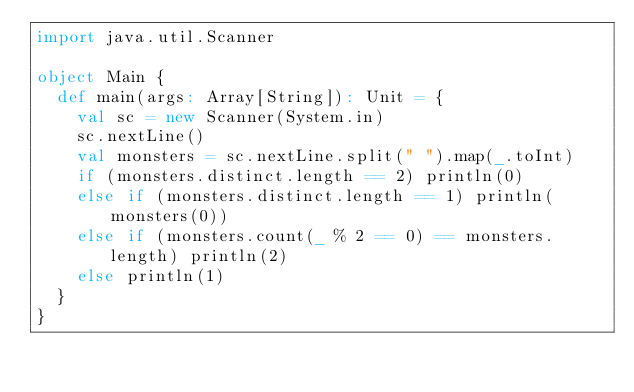Convert code to text. <code><loc_0><loc_0><loc_500><loc_500><_Scala_>import java.util.Scanner

object Main {
  def main(args: Array[String]): Unit = {
    val sc = new Scanner(System.in)
    sc.nextLine()
    val monsters = sc.nextLine.split(" ").map(_.toInt)
    if (monsters.distinct.length == 2) println(0)
    else if (monsters.distinct.length == 1) println(monsters(0))
    else if (monsters.count(_ % 2 == 0) == monsters.length) println(2)
    else println(1)
  }
}
</code> 